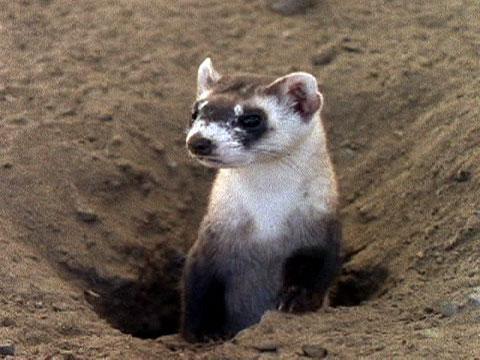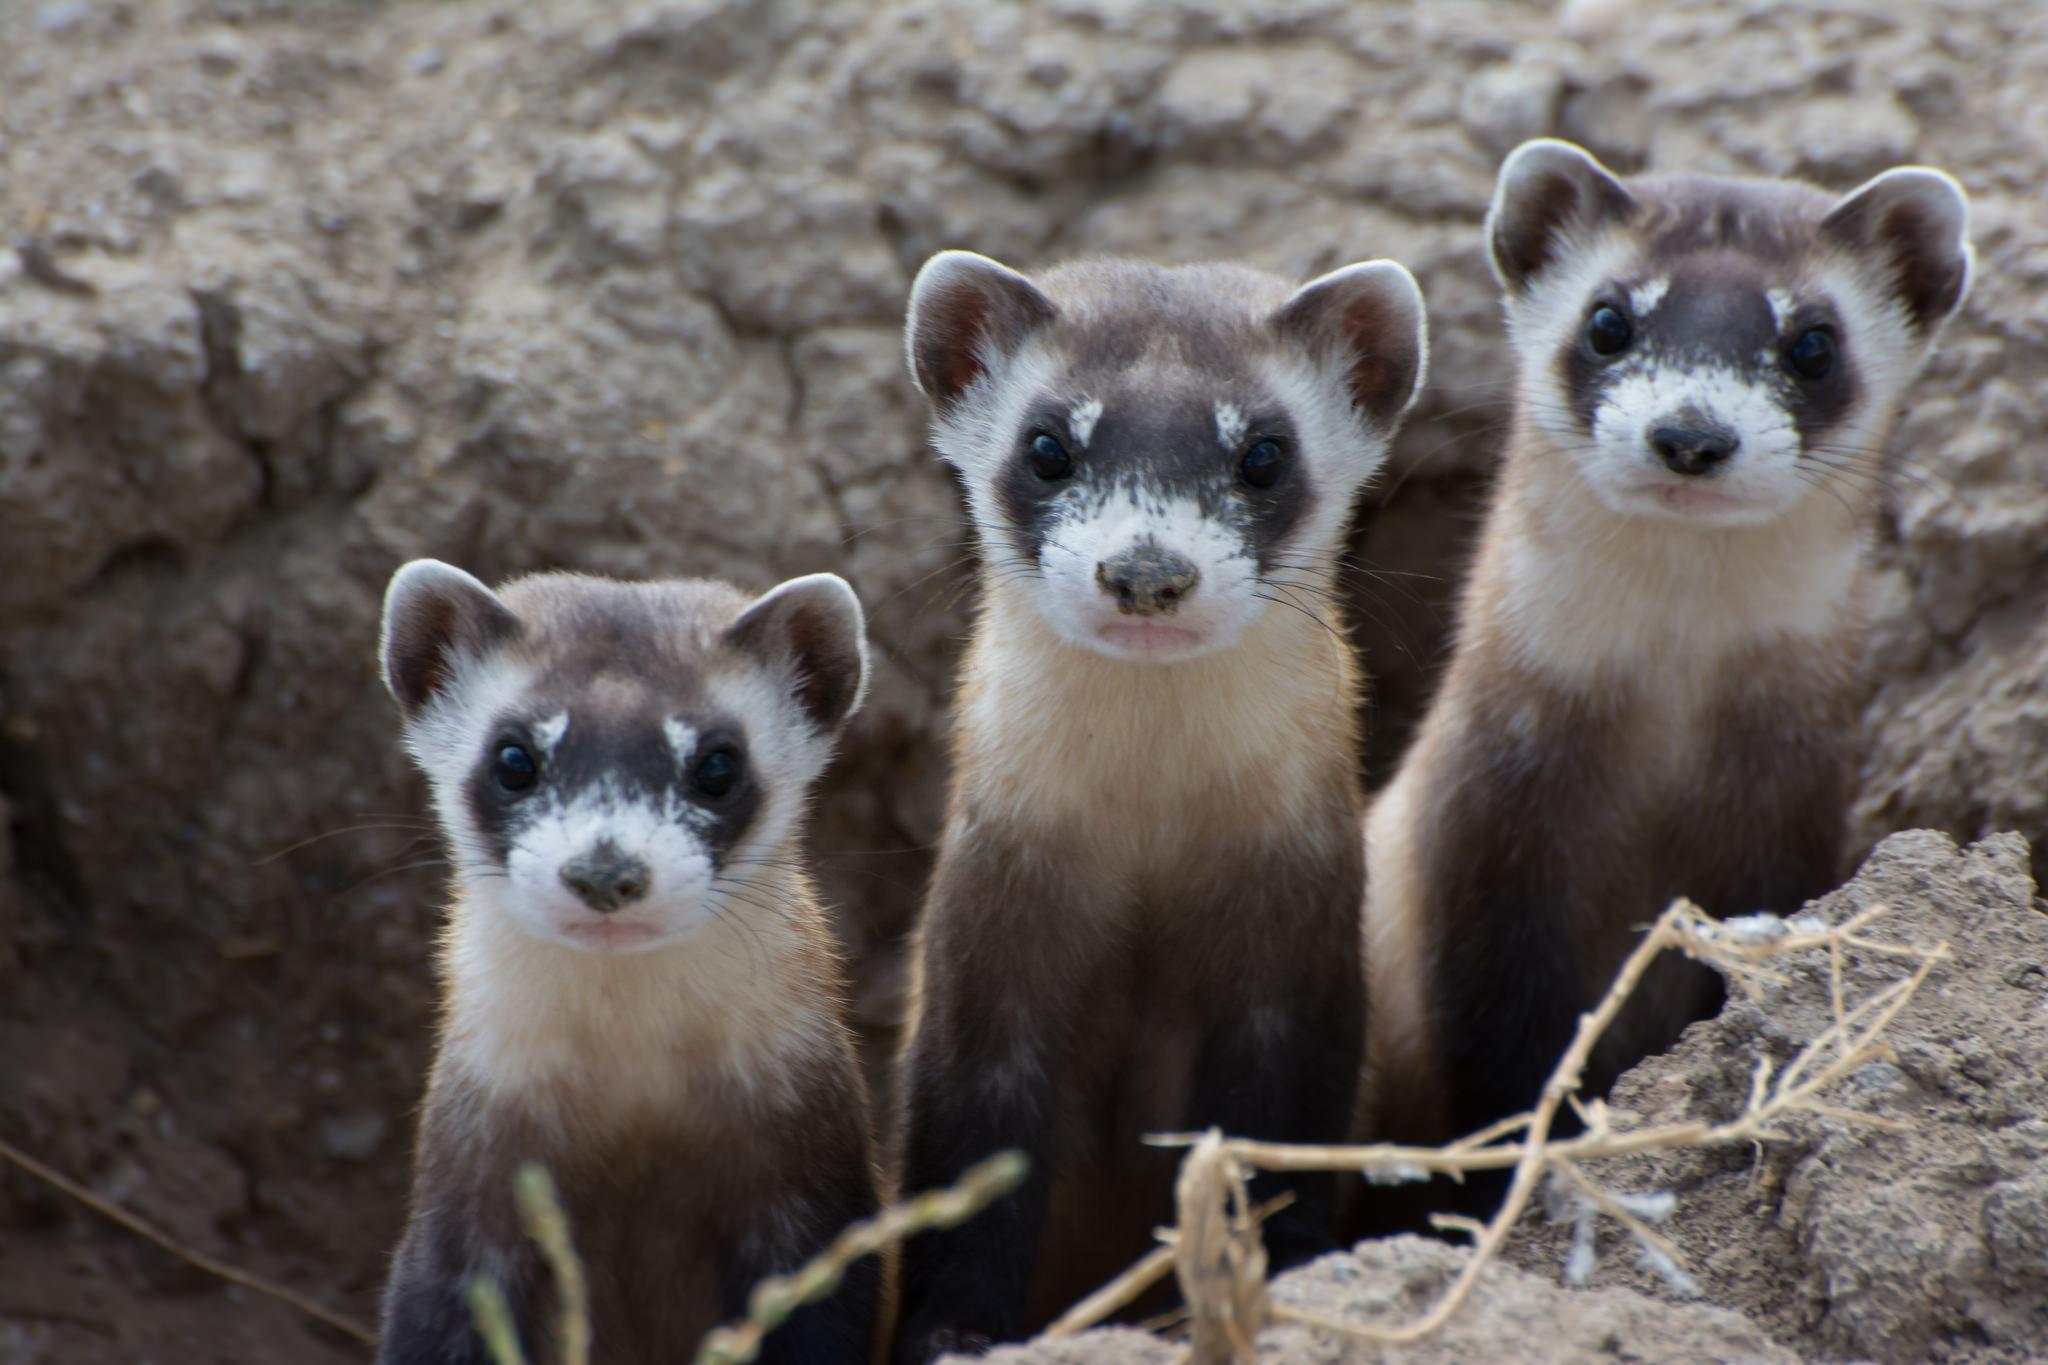The first image is the image on the left, the second image is the image on the right. Considering the images on both sides, is "The images contain a total of four ferrets." valid? Answer yes or no. Yes. The first image is the image on the left, the second image is the image on the right. For the images displayed, is the sentence "There are no more than three ferrets" factually correct? Answer yes or no. No. 